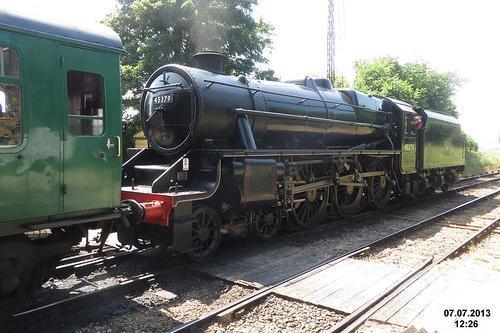How many trains are on the tracks?
Give a very brief answer. 1. 